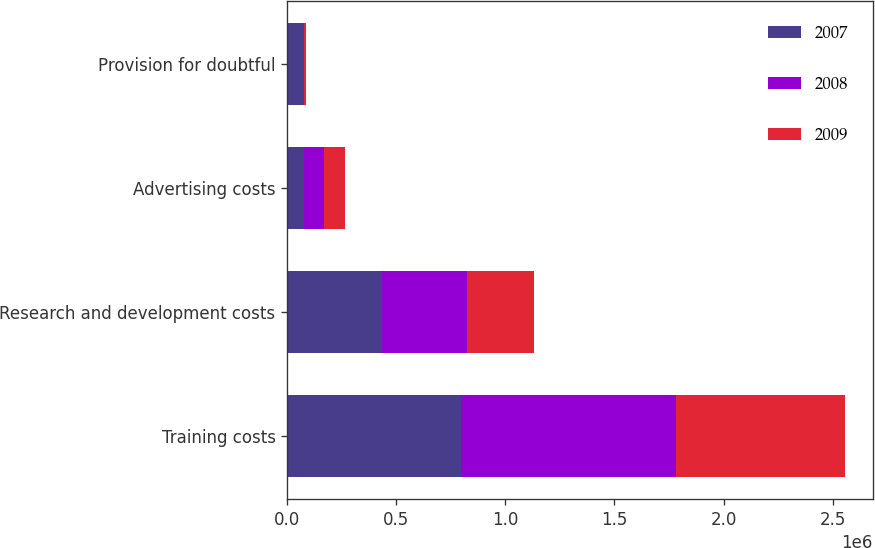<chart> <loc_0><loc_0><loc_500><loc_500><stacked_bar_chart><ecel><fcel>Training costs<fcel>Research and development costs<fcel>Advertising costs<fcel>Provision for doubtful<nl><fcel>2007<fcel>794218<fcel>434937<fcel>77315<fcel>75008<nl><fcel>2008<fcel>985929<fcel>390168<fcel>91034<fcel>1772<nl><fcel>2009<fcel>775768<fcel>307357<fcel>94404<fcel>9441<nl></chart> 